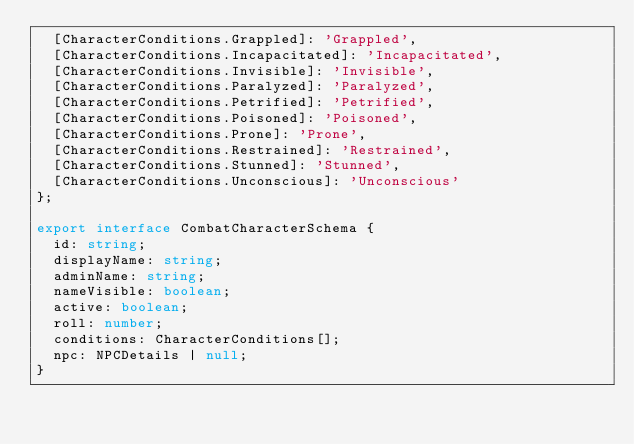<code> <loc_0><loc_0><loc_500><loc_500><_TypeScript_>  [CharacterConditions.Grappled]: 'Grappled',
  [CharacterConditions.Incapacitated]: 'Incapacitated',
  [CharacterConditions.Invisible]: 'Invisible',
  [CharacterConditions.Paralyzed]: 'Paralyzed',
  [CharacterConditions.Petrified]: 'Petrified',
  [CharacterConditions.Poisoned]: 'Poisoned',
  [CharacterConditions.Prone]: 'Prone',
  [CharacterConditions.Restrained]: 'Restrained',
  [CharacterConditions.Stunned]: 'Stunned',
  [CharacterConditions.Unconscious]: 'Unconscious'
};

export interface CombatCharacterSchema {
  id: string;
  displayName: string;
  adminName: string;
  nameVisible: boolean;
  active: boolean;
  roll: number;
  conditions: CharacterConditions[];
  npc: NPCDetails | null;
}
</code> 